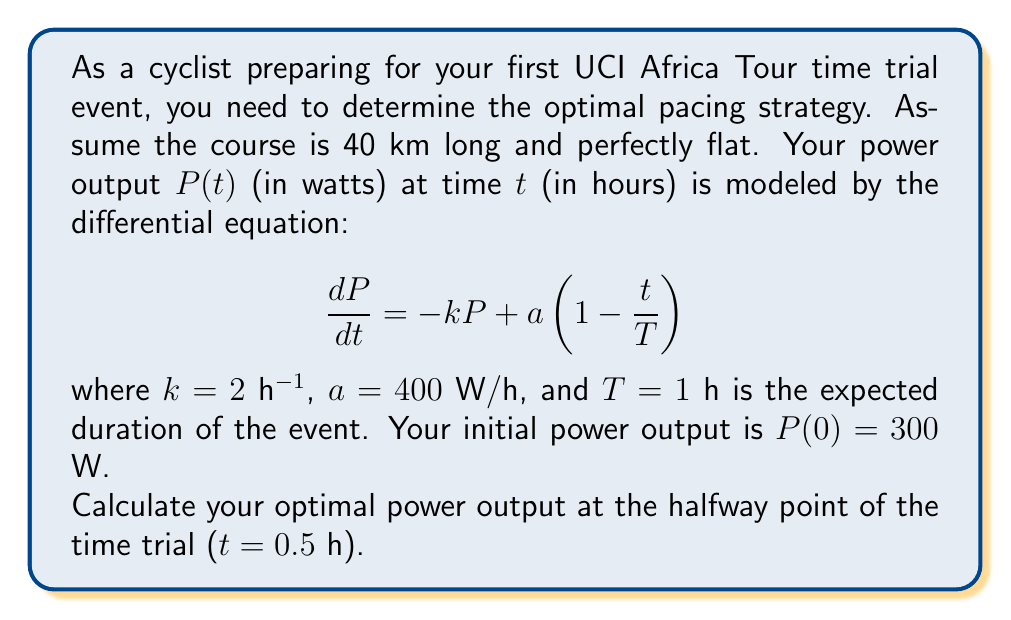Could you help me with this problem? To solve this problem, we need to follow these steps:

1) First, we need to solve the given differential equation. This is a first-order linear differential equation.

2) The general solution for this type of equation is:

   $$P(t) = e^{-kt}(\int ae^{kt}(1-\frac{t}{T})dt + C)$$

3) Solving the integral:

   $$\int ae^{kt}(1-\frac{t}{T})dt = \frac{a}{k}e^{kt} - \frac{a}{kT}te^{kt} + \frac{a}{k^2T}e^{kt} + C_1$$

4) Substituting this back into the general solution:

   $$P(t) = \frac{a}{k} - \frac{a}{kT}t + \frac{a}{k^2T} + Ce^{-kt}$$

5) Now we can use the initial condition $P(0) = 300$ to find C:

   $$300 = \frac{400}{2} + \frac{400}{2^2 \cdot 1} + C$$
   $$C = 300 - 200 - 100 = 0$$

6) Therefore, our particular solution is:

   $$P(t) = \frac{a}{k} - \frac{a}{kT}t + \frac{a}{k^2T} = 200 - 200t + 100$$

7) To find the power output at the halfway point, we substitute t = 0.5 h:

   $$P(0.5) = 200 - 200(0.5) + 100 = 200$$

Thus, the optimal power output at the halfway point of the time trial is 200 W.
Answer: 200 W 